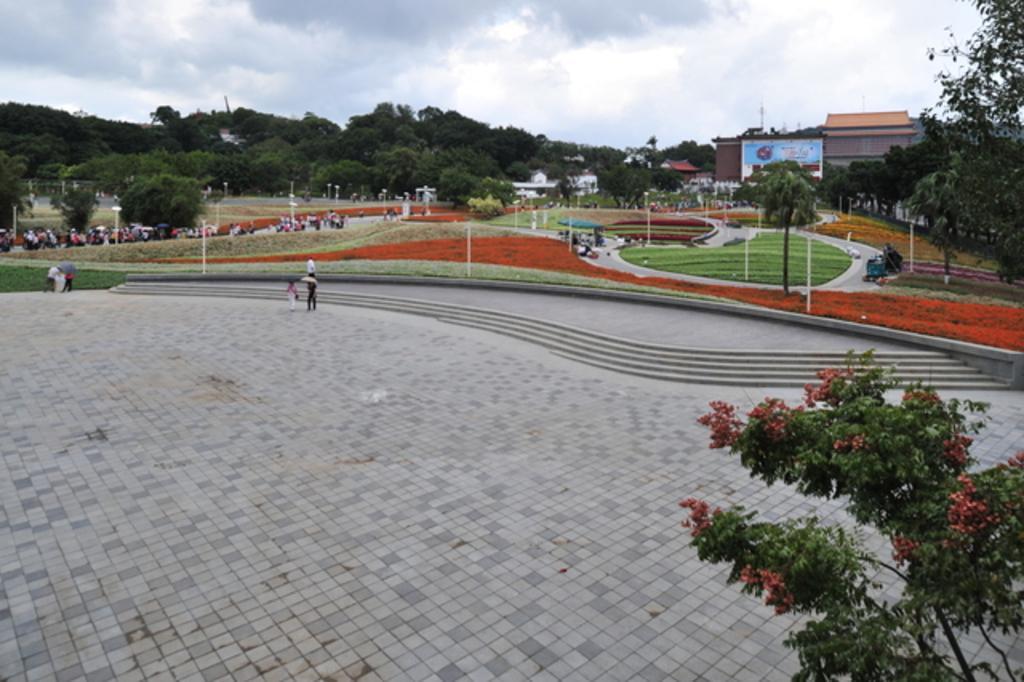Could you give a brief overview of what you see in this image? This image consists of many people. At the bottom, there is a floor. On the right, there are plants. And we can see a building in this image. On the left, there are many trees. At the top, there are clouds in the sky. 